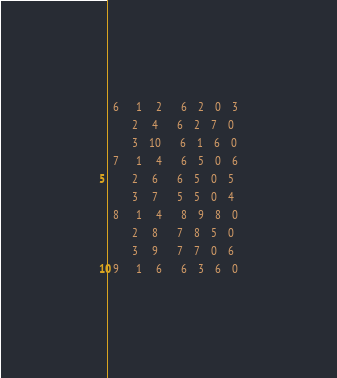<code> <loc_0><loc_0><loc_500><loc_500><_ObjectiveC_>  6      1     2       6    2    0    3
         2     4       6    2    7    0
         3    10       6    1    6    0
  7      1     4       6    5    0    6
         2     6       6    5    0    5
         3     7       5    5    0    4
  8      1     4       8    9    8    0
         2     8       7    8    5    0
         3     9       7    7    0    6
  9      1     6       6    3    6    0</code> 